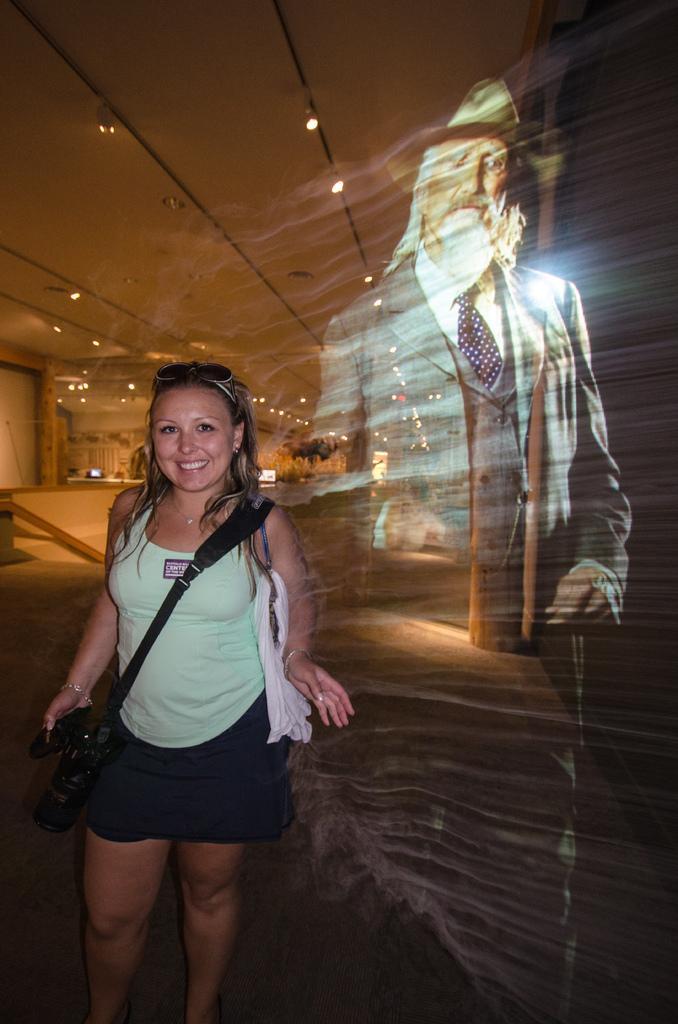In one or two sentences, can you explain what this image depicts? In this image there is a woman standing towards the bottom of the image, she is holding an object, she is wearing a bag, there is a man, there is floor towards the bottom of the image, there is an object towards the left of the image, there is a wall towards the left of the image, there is roof towards the top of the image, there are lights. 